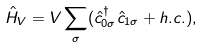<formula> <loc_0><loc_0><loc_500><loc_500>\hat { H } _ { V } = V \sum _ { \sigma } ( \hat { c } _ { 0 \sigma } ^ { \dag } \hat { c } _ { 1 \sigma } + h . c . ) ,</formula> 